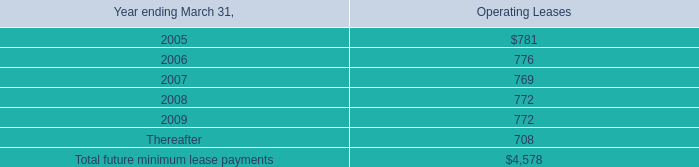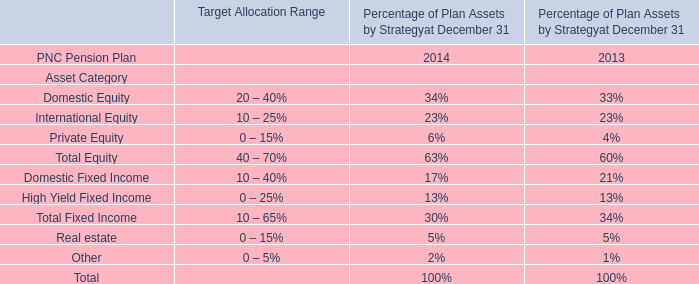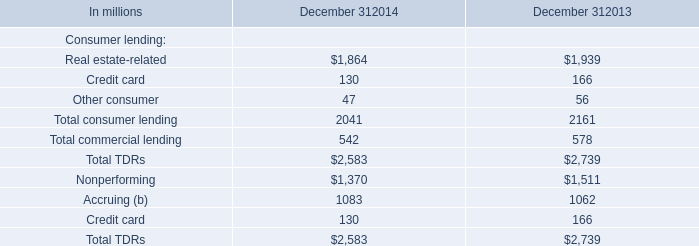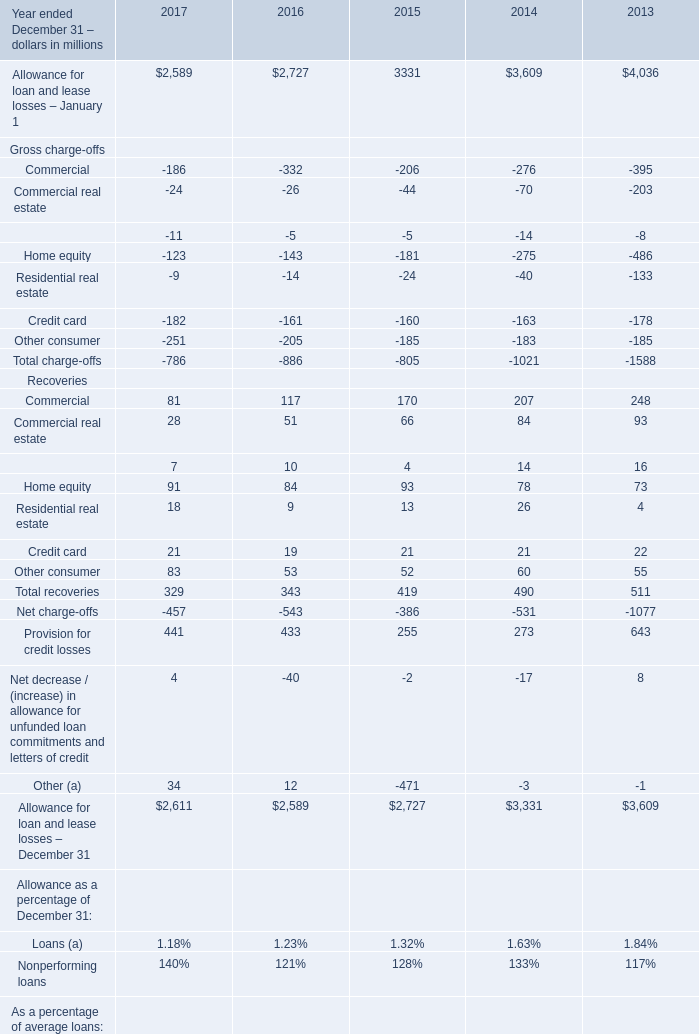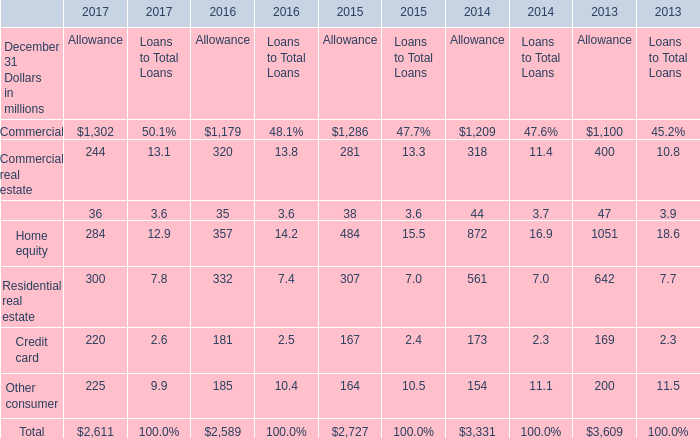Does Allowance for loan and lease losses – January 1 keeps increasing each year between 2017 and 2016? 
Answer: No. 